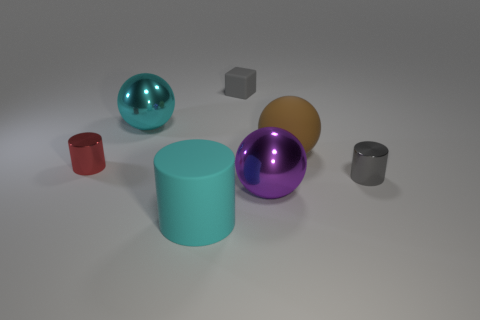What materials do the objects in the image appear to be made from? The objects give an impression of being made from various materials. The spheres have a reflective surface, suggestive of a polished metal or plastic, whereas the cylindrical objects might be either matte plastic or a metal with a soft finish. The small cube appears to have a rubber-like texture. 